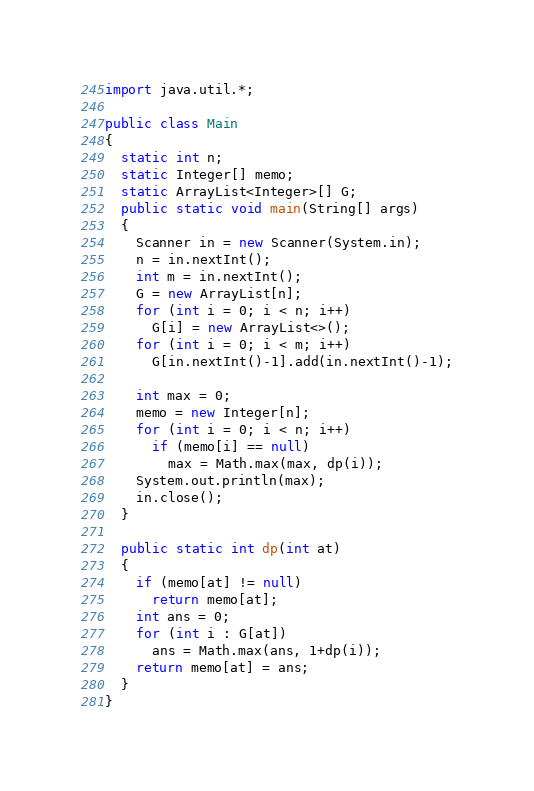<code> <loc_0><loc_0><loc_500><loc_500><_Java_>import java.util.*;

public class Main
{
  static int n;
  static Integer[] memo;
  static ArrayList<Integer>[] G;
  public static void main(String[] args)
  {
	Scanner in = new Scanner(System.in);
    n = in.nextInt();
    int m = in.nextInt();
    G = new ArrayList[n];
    for (int i = 0; i < n; i++)
      G[i] = new ArrayList<>();
    for (int i = 0; i < m; i++)
      G[in.nextInt()-1].add(in.nextInt()-1);
    
    int max = 0;
    memo = new Integer[n];
    for (int i = 0; i < n; i++)
      if (memo[i] == null)
        max = Math.max(max, dp(i));
    System.out.println(max);
    in.close();
  }
  
  public static int dp(int at)
  {
    if (memo[at] != null)
      return memo[at];
    int ans = 0;
    for (int i : G[at])
      ans = Math.max(ans, 1+dp(i));
    return memo[at] = ans;
  }
}
</code> 